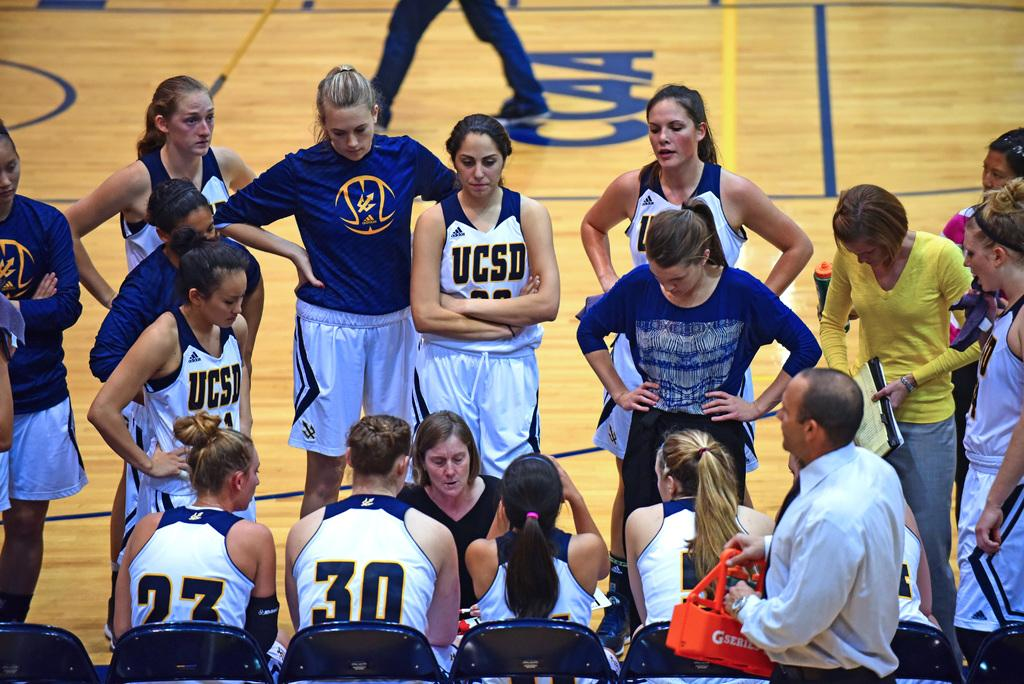<image>
Summarize the visual content of the image. The UCSD basketball team huddles with their coach during a timeout 